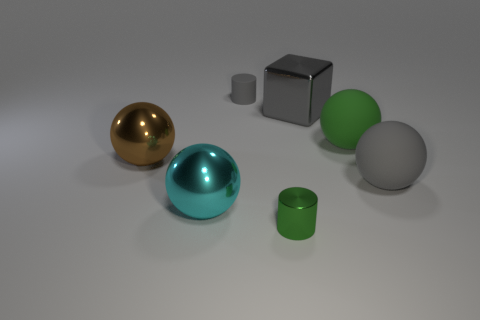The tiny matte object that is the same color as the metal block is what shape?
Keep it short and to the point. Cylinder. What is the material of the ball that is the same color as the matte cylinder?
Keep it short and to the point. Rubber. Are there any brown shiny objects of the same size as the gray metallic block?
Provide a short and direct response. Yes. Is the number of green matte objects on the left side of the large green thing the same as the number of green cylinders that are behind the brown shiny thing?
Provide a succinct answer. Yes. Are the cylinder behind the big cyan object and the large gray thing that is behind the big brown metallic object made of the same material?
Give a very brief answer. No. What material is the gray cylinder?
Your answer should be compact. Rubber. How many other objects are the same color as the big cube?
Provide a succinct answer. 2. Is the rubber cylinder the same color as the shiny cube?
Offer a very short reply. Yes. How many gray matte things are there?
Keep it short and to the point. 2. There is a cylinder that is in front of the gray matte thing that is right of the large shiny block; what is its material?
Your answer should be compact. Metal. 